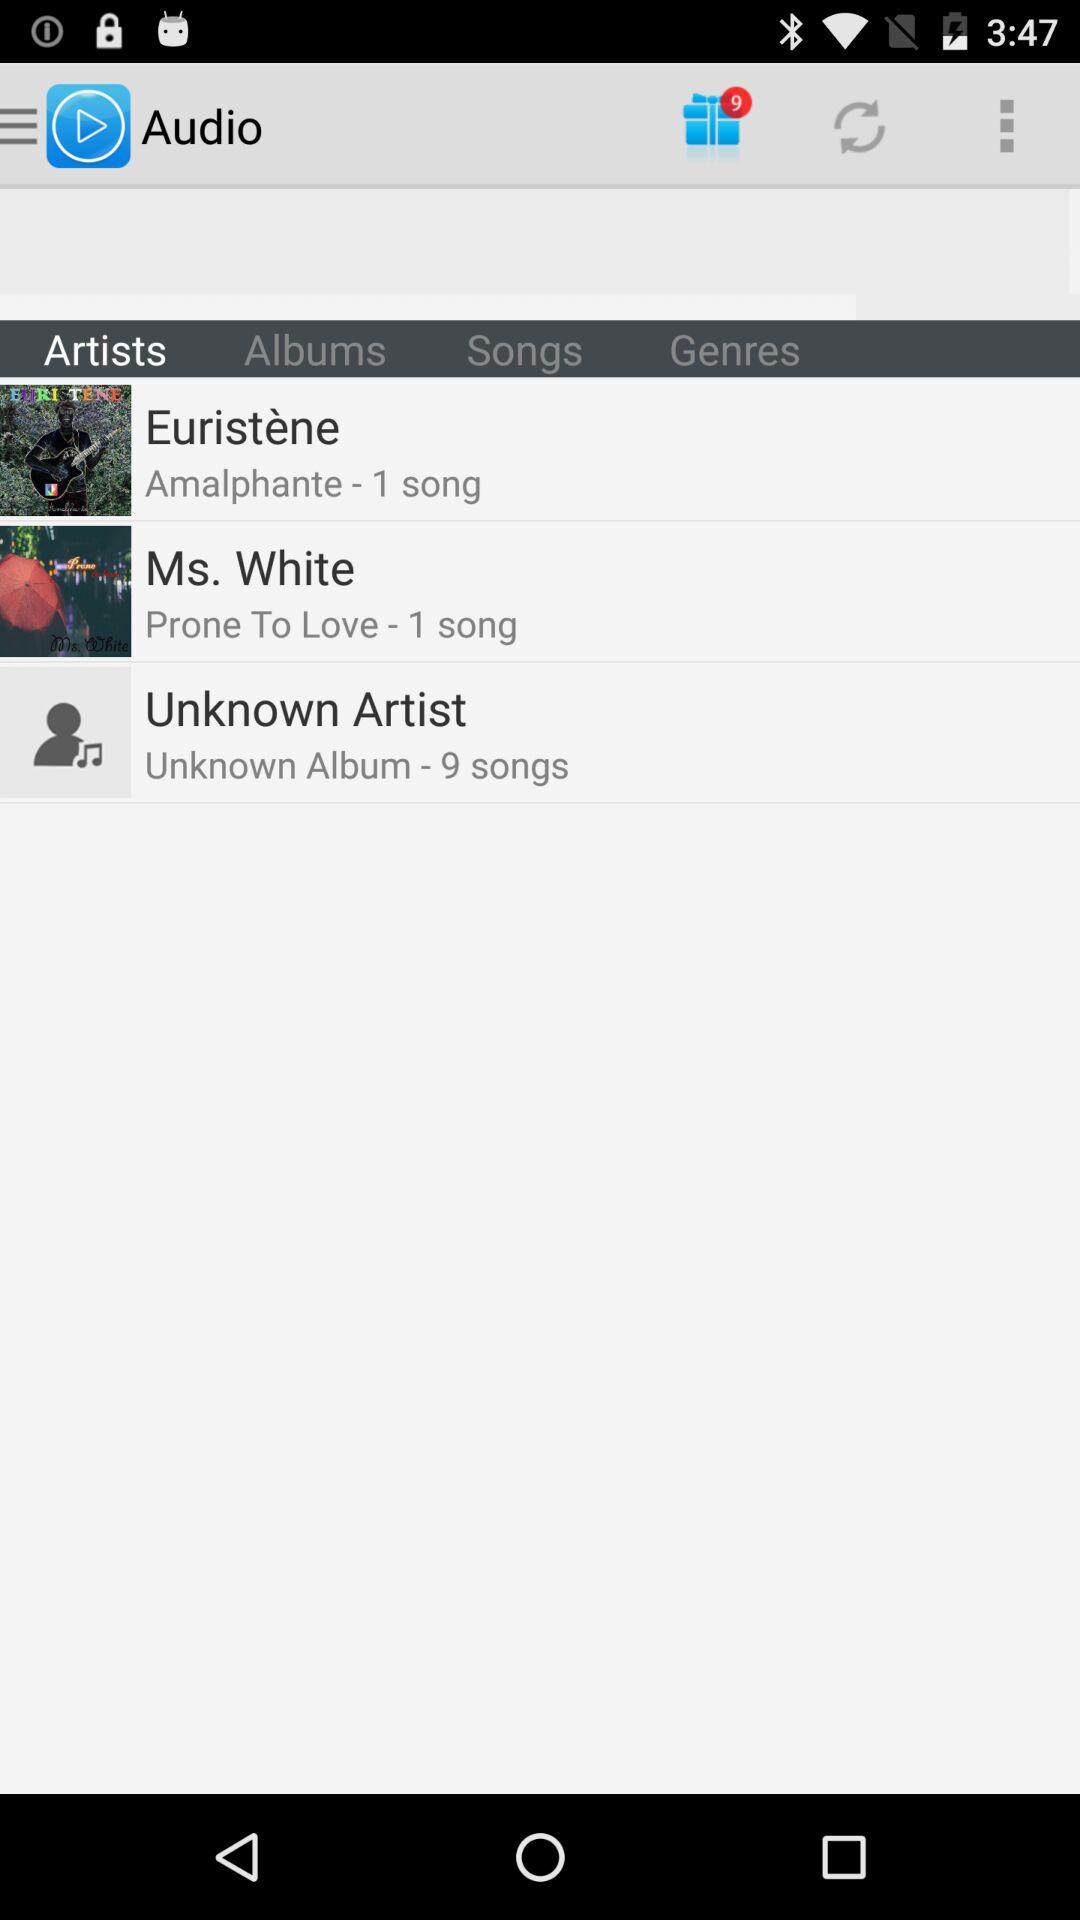How many gift notifications are there? There are 9 gift notifications. 